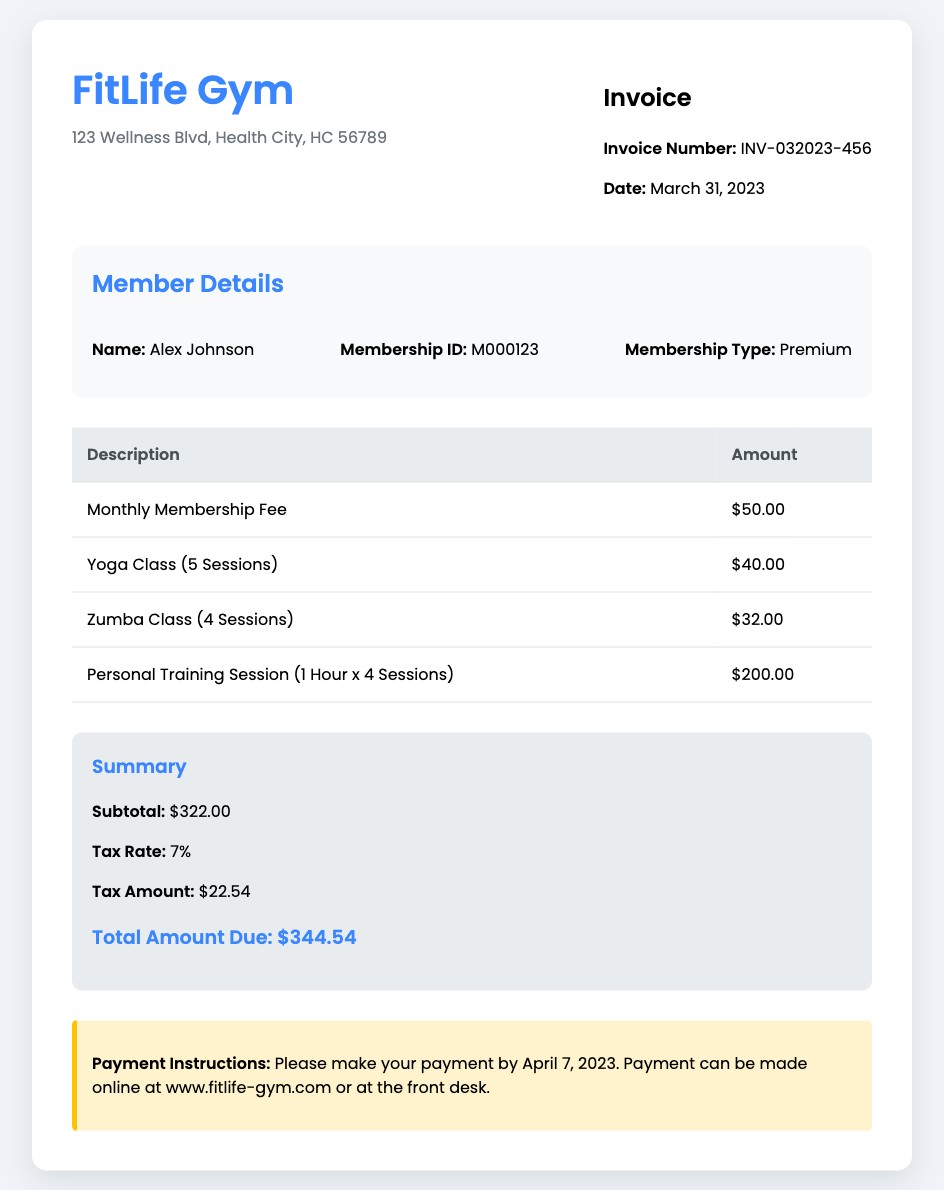What is the invoice number? The invoice number is a unique identifier for this document, mentioned at the top of the invoice.
Answer: INV-032023-456 What is the membership type of the member? The membership type is listed in the member details section of the invoice.
Answer: Premium How much is the tax amount? The tax amount is calculated and provided in the summary section of the invoice.
Answer: $22.54 How many yoga class sessions were charged? The invoice details the number of yoga class sessions in the itemized charges.
Answer: 5 Sessions What is the amount due after tax? The total amount due is listed at the bottom of the summary section of the invoice.
Answer: $344.54 What is the date by which payment should be made? The payment instructions specify a deadline for the payment, which is mentioned in that section.
Answer: April 7, 2023 How many personal training sessions were billed? The number of personal training sessions is specified in the description of the charges.
Answer: 4 Sessions What is the subtotal before tax? The subtotal is provided in the summary section, reflecting the total of all charges before tax is added.
Answer: $322.00 What city is FitLife Gym located in? The gym's location is given in the address at the top of the invoice.
Answer: Health City 